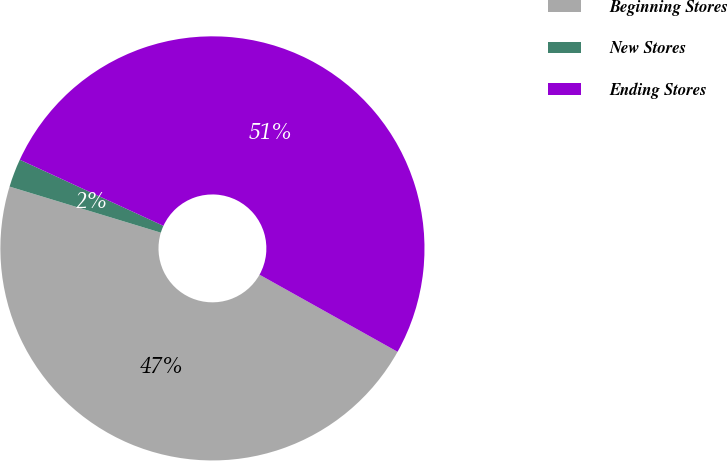Convert chart. <chart><loc_0><loc_0><loc_500><loc_500><pie_chart><fcel>Beginning Stores<fcel>New Stores<fcel>Ending Stores<nl><fcel>46.6%<fcel>2.16%<fcel>51.24%<nl></chart> 